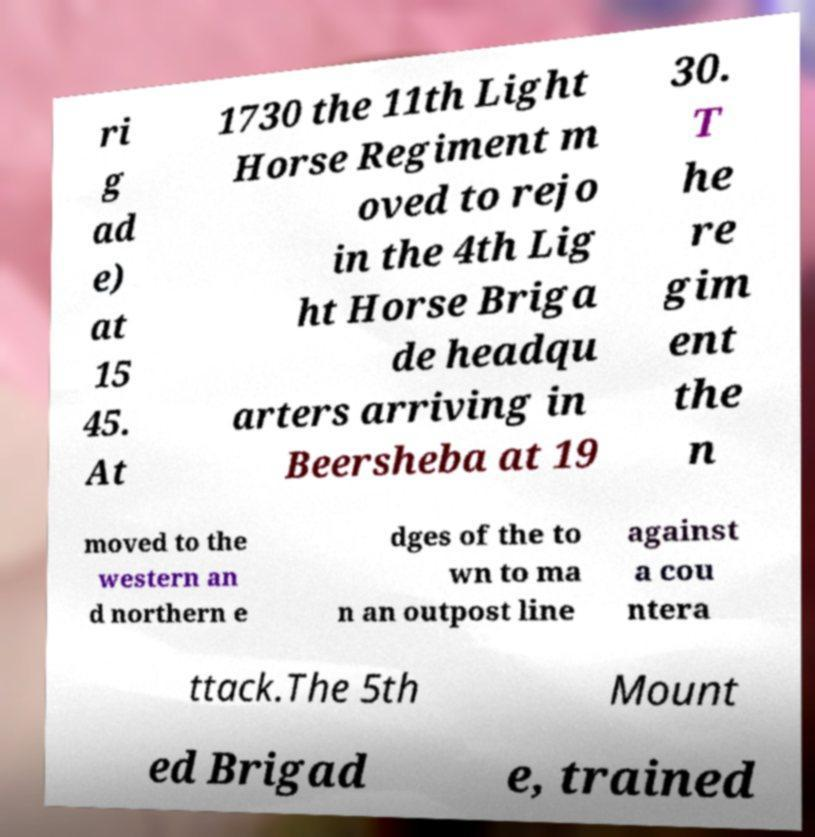Please identify and transcribe the text found in this image. ri g ad e) at 15 45. At 1730 the 11th Light Horse Regiment m oved to rejo in the 4th Lig ht Horse Briga de headqu arters arriving in Beersheba at 19 30. T he re gim ent the n moved to the western an d northern e dges of the to wn to ma n an outpost line against a cou ntera ttack.The 5th Mount ed Brigad e, trained 